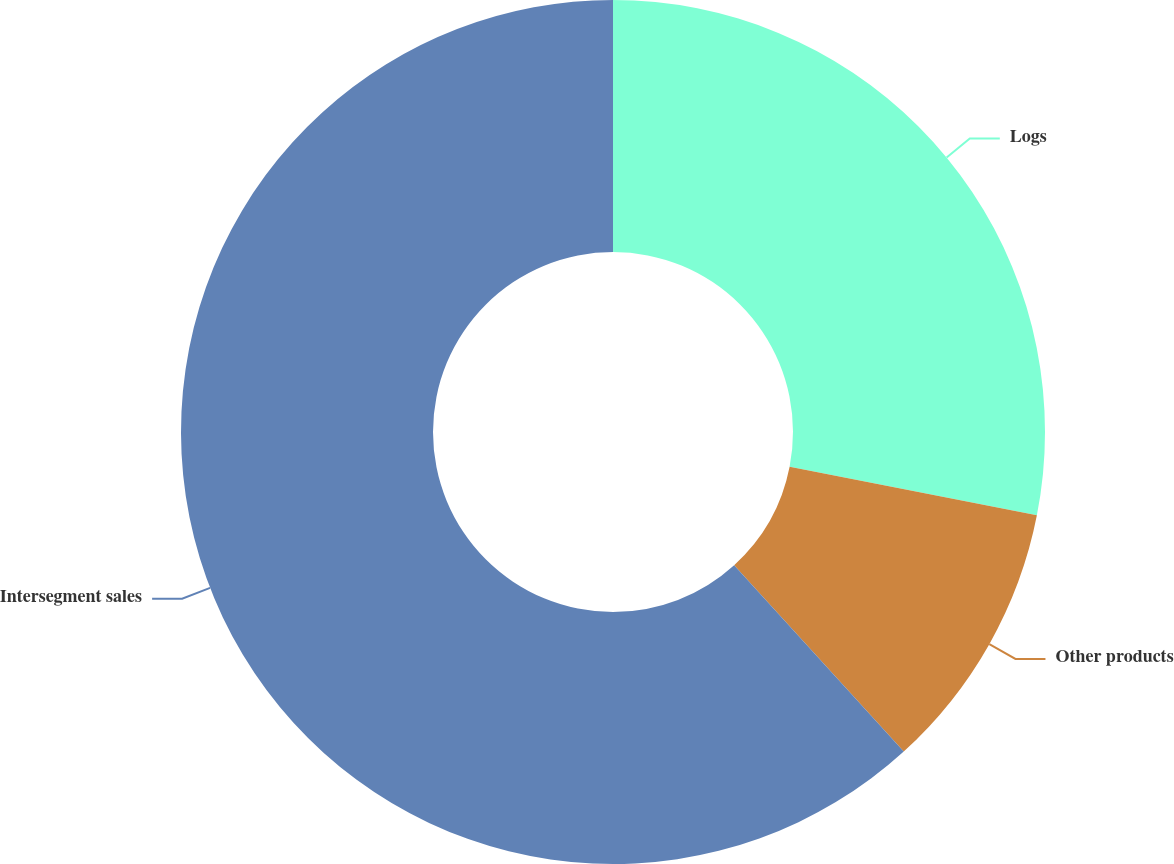Convert chart. <chart><loc_0><loc_0><loc_500><loc_500><pie_chart><fcel>Logs<fcel>Other products<fcel>Intersegment sales<nl><fcel>28.09%<fcel>10.16%<fcel>61.75%<nl></chart> 